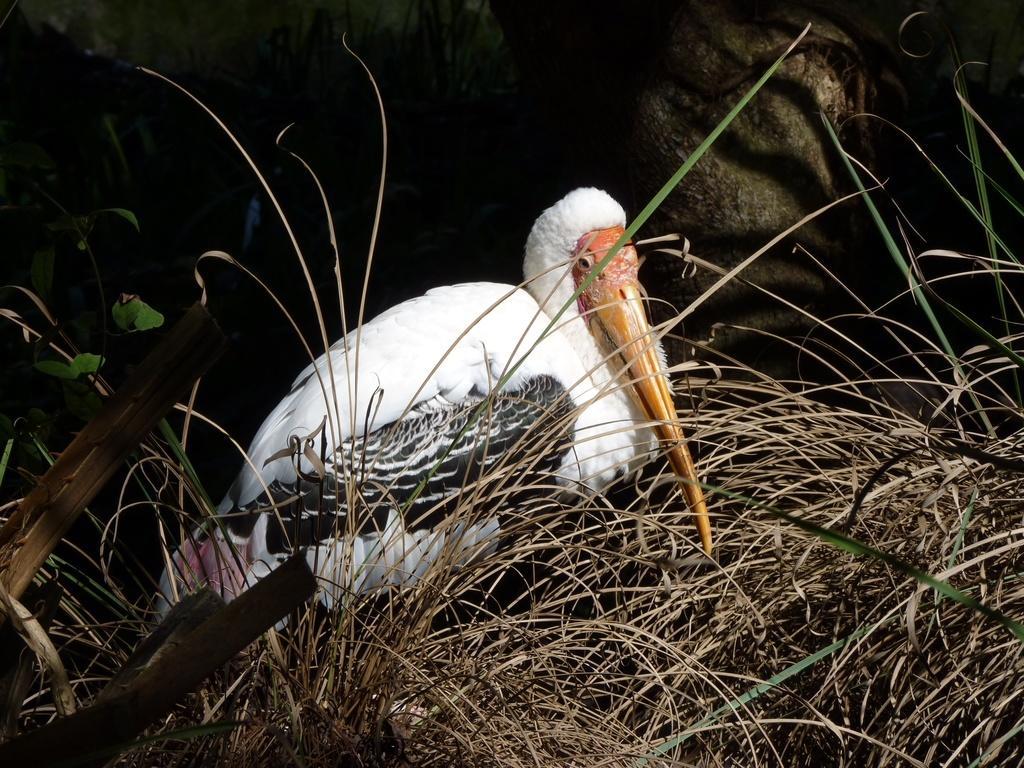Can you describe this image briefly? In this picture we can observe a white color crane with yellow color peak. There is dried grass. The background is dark. 